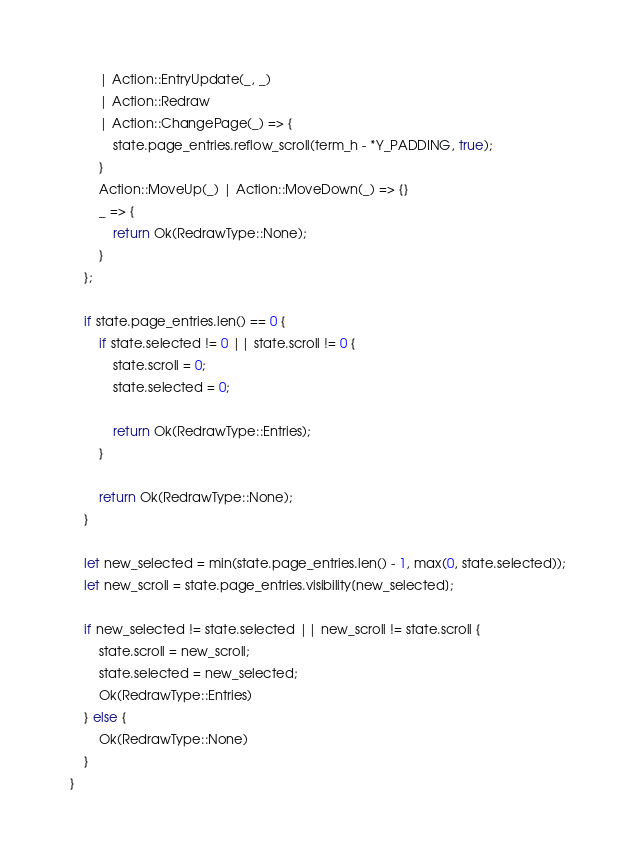Convert code to text. <code><loc_0><loc_0><loc_500><loc_500><_Rust_>        | Action::EntryUpdate(_, _)
        | Action::Redraw
        | Action::ChangePage(_) => {
            state.page_entries.reflow_scroll(term_h - *Y_PADDING, true);
        }
        Action::MoveUp(_) | Action::MoveDown(_) => {}
        _ => {
            return Ok(RedrawType::None);
        }
    };

    if state.page_entries.len() == 0 {
        if state.selected != 0 || state.scroll != 0 {
            state.scroll = 0;
            state.selected = 0;

            return Ok(RedrawType::Entries);
        }

        return Ok(RedrawType::None);
    }

    let new_selected = min(state.page_entries.len() - 1, max(0, state.selected));
    let new_scroll = state.page_entries.visibility[new_selected];

    if new_selected != state.selected || new_scroll != state.scroll {
        state.scroll = new_scroll;
        state.selected = new_selected;
        Ok(RedrawType::Entries)
    } else {
        Ok(RedrawType::None)
    }
}
</code> 